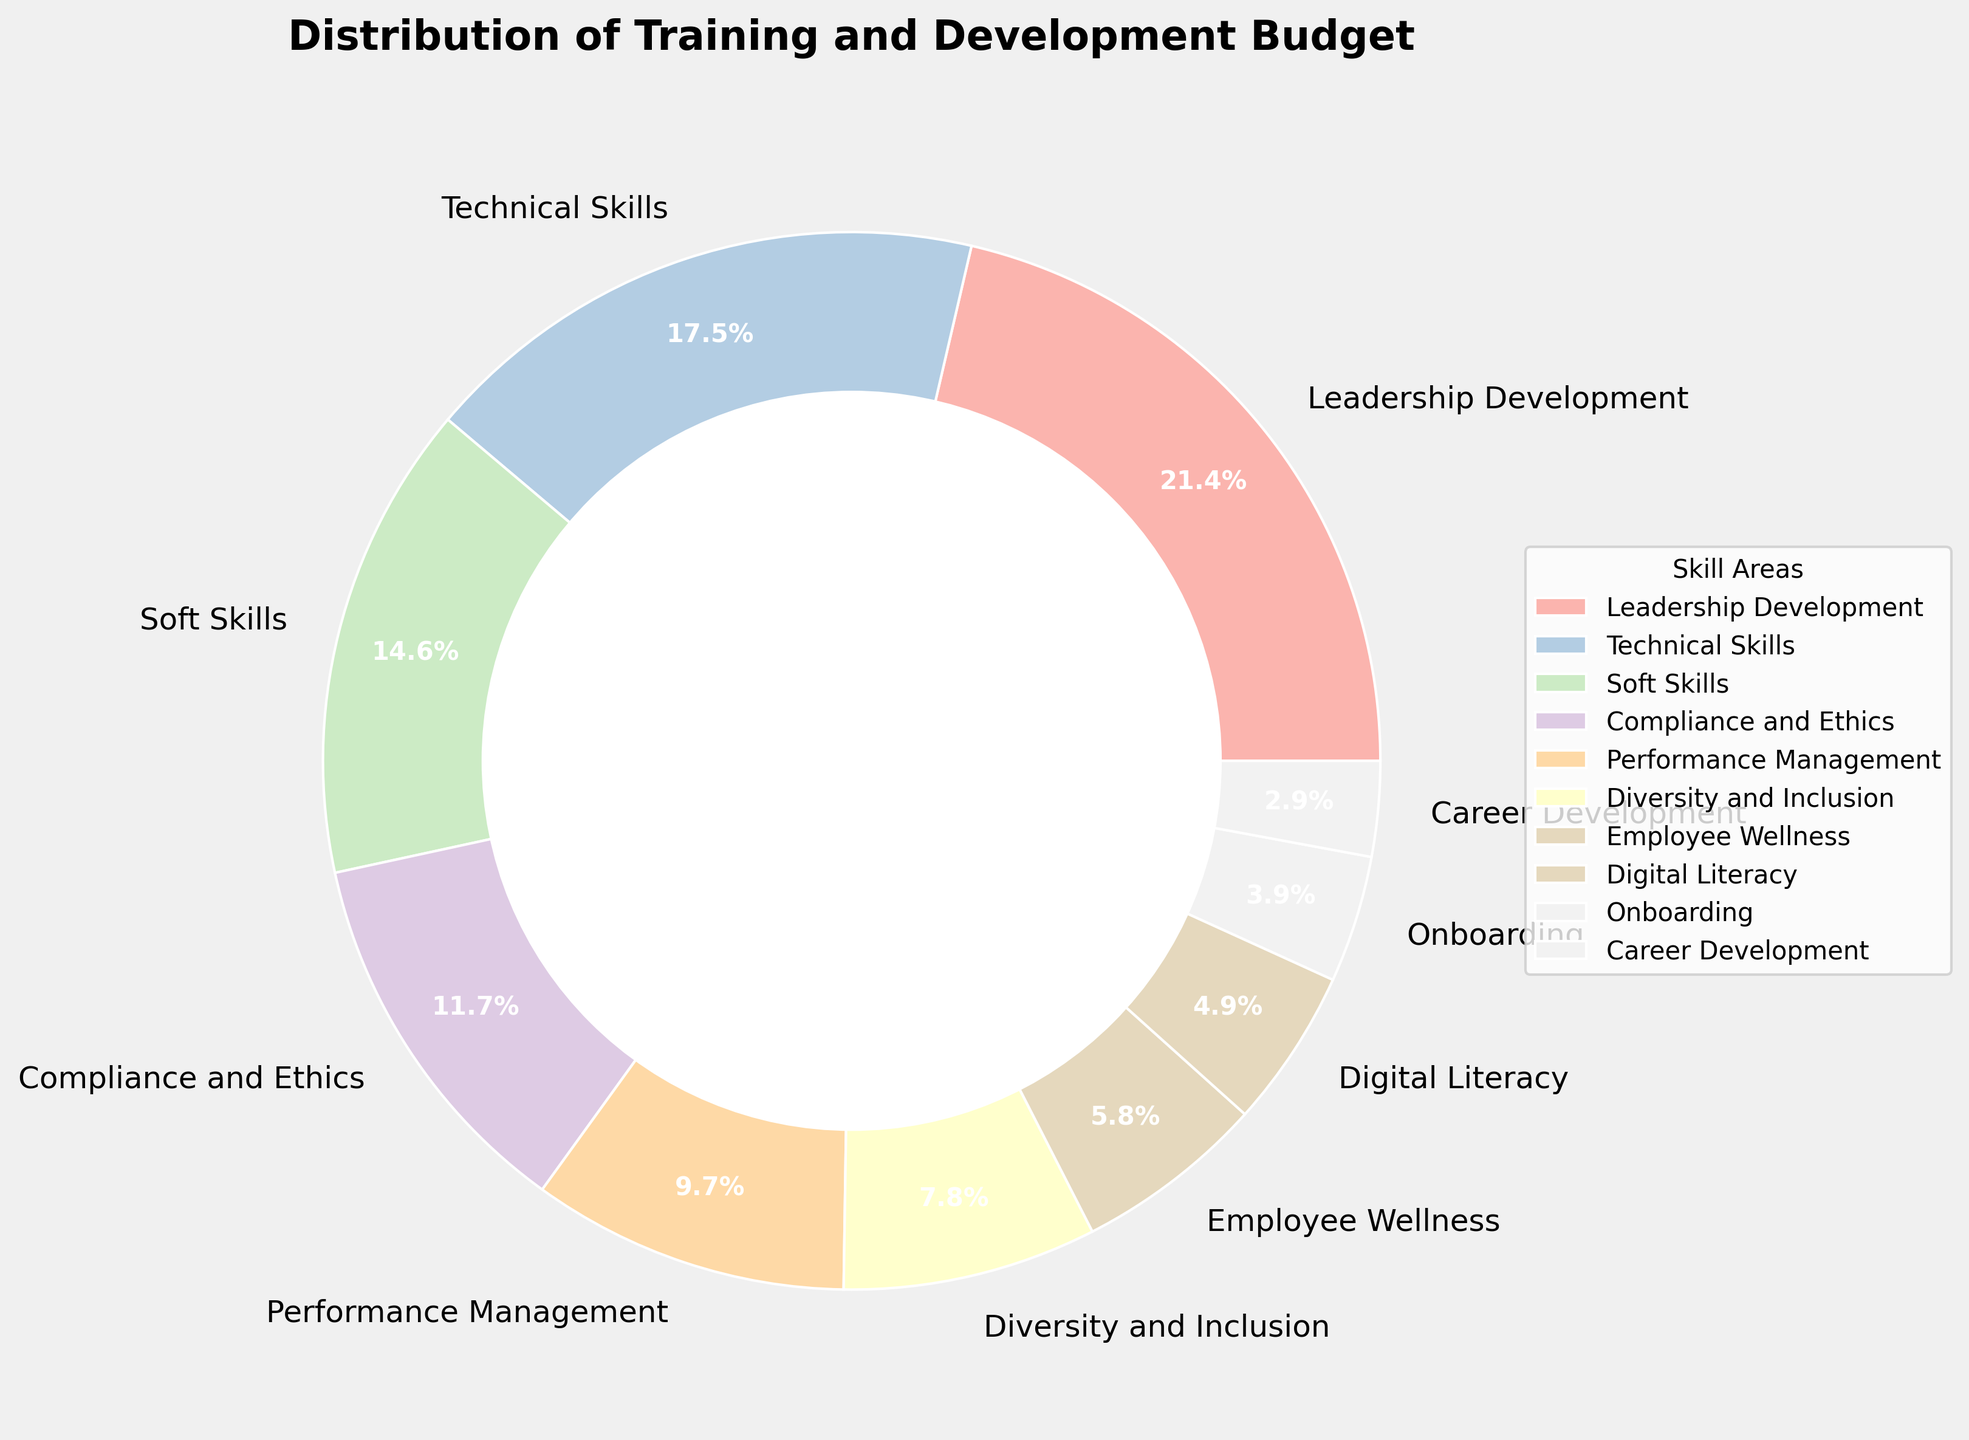What's the largest allocation in the training and development budget? The largest pie slice represents the skill area with the highest budget allocation. From the labels, "Leadership Development" has the largest slice, which is 22%.
Answer: Leadership Development (22%) Which skill area has the smallest budget allocation? The smallest pie slice represents the skill area with the lowest budget allocation. From the labels, "Career Development" has the smallest slice, which is 3%.
Answer: Career Development (3%) How much more budget is allocated to Leadership Development compared to Employee Wellness? Subtract the budget allocation of Employee Wellness from that of Leadership Development. So, 22% - 6% = 16%.
Answer: 16% Does the combined budget for Soft Skills and Technical Skills exceed the allocation for Leadership Development? Add the budget allocations for Soft Skills and Technical Skills and compare to Leadership Development: 15% + 18% = 33%, which is greater than 22%.
Answer: Yes, it exceeds Which allocation is closer to 10%, Performance Management or Onboarding? Compare the budget allocations of Performance Management (10%) and Onboarding (4%) to 10%. Performance Management is exactly 10%, making it closer.
Answer: Performance Management How does the budget for Compliance and Ethics compare to that for Diversity and Inclusion? Compare the budget allocations: Compliance and Ethics has 12%, and Diversity and Inclusion has 8%. 12% is greater than 8%.
Answer: Compliance and Ethics has a greater allocation What is the combined budget allocation for Digital Literacy, Onboarding, and Career Development? Add the budget allocations for the three skill areas: 5% + 4% + 3% = 12%.
Answer: 12% Which skill area has a larger budget allocation: Employee Wellness or Digital Literacy? Compare the budget allocations: Employee Wellness has 6% and Digital Literacy has 5%. 6% is greater than 5%.
Answer: Employee Wellness How much budget is allocated in total to Leadership Development, Technical Skills, and Soft Skills? Add the budget allocations: Leadership Development (22%), Technical Skills (18%), and Soft Skills (15%). So, 22% + 18% + 15% = 55%.
Answer: 55% Is the budget allocation for Diversity and Inclusion the second smallest? Compare all the budget allocations. The smallest is Career Development (3%), next smallest is Onboarding (4%), and then comes Diversity and Inclusion (8%), which is the third smallest.
Answer: No 